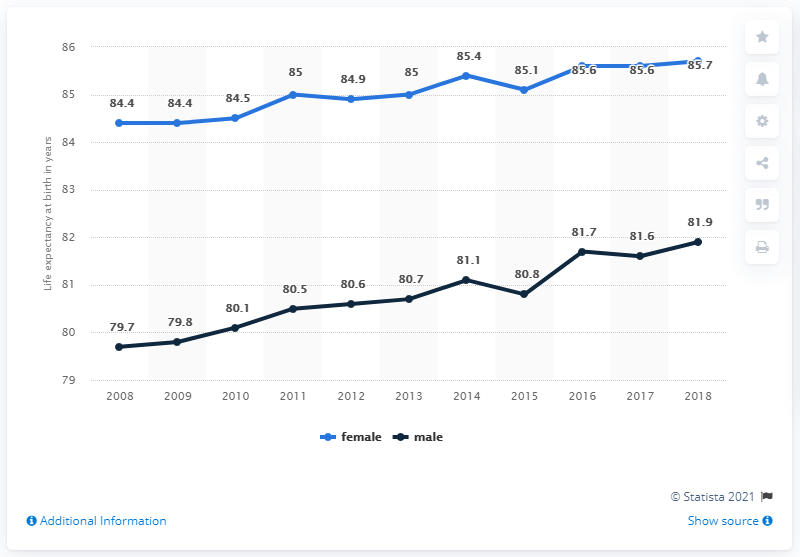Point out several critical features in this image. In the male line graph, the data moved from 2008 to 2018, resulting in a total increase of 2.2 points over the course of ten years. In 2011, the value for females was 85%, as indicated by the blue bar on the graph. 